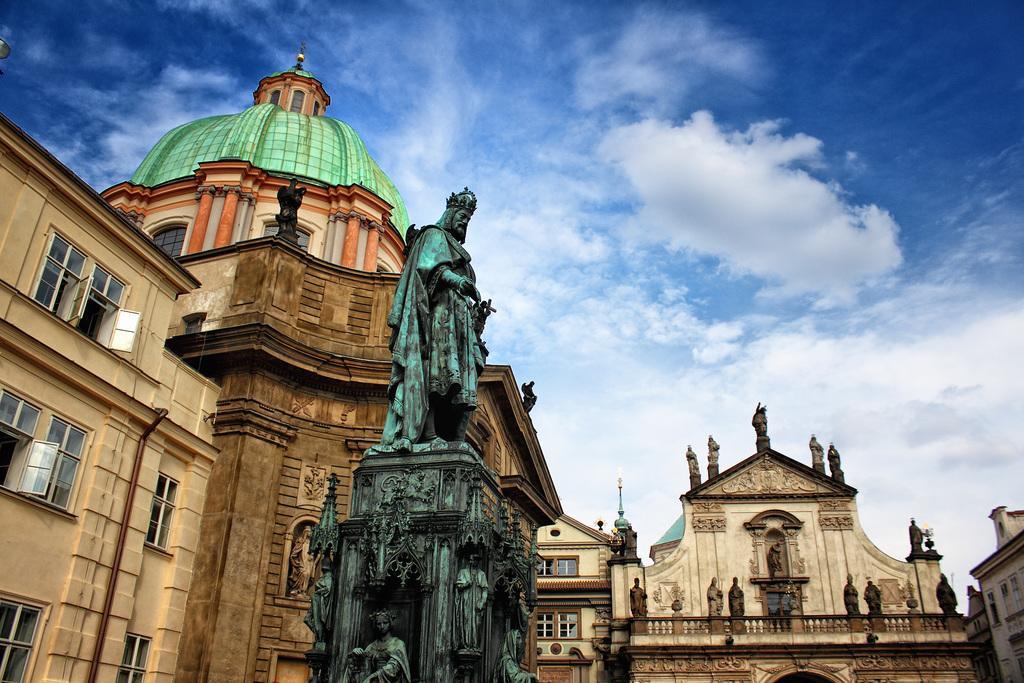Describe this image in one or two sentences. In this image we can see a statue, few buildings, a building with statues and the sky with clouds in the background. 